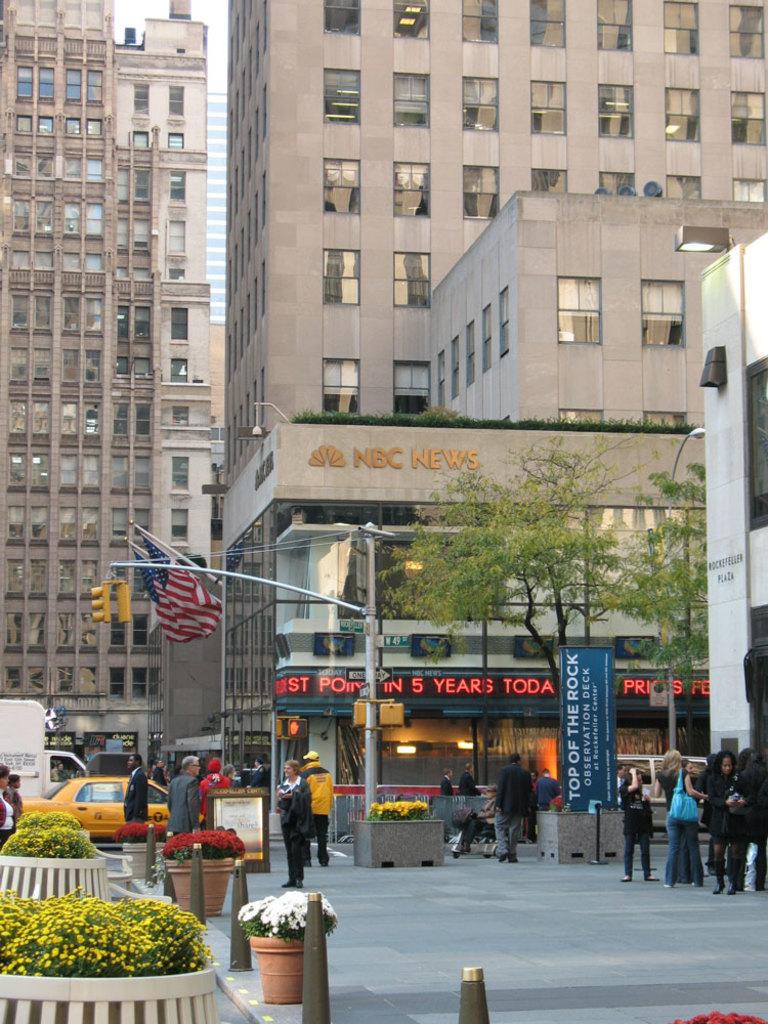Provide a one-sentence caption for the provided image. An NBC News building with an American flag hanging off the side. 